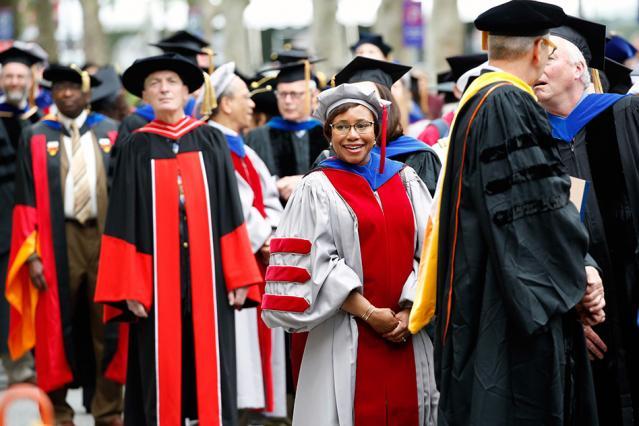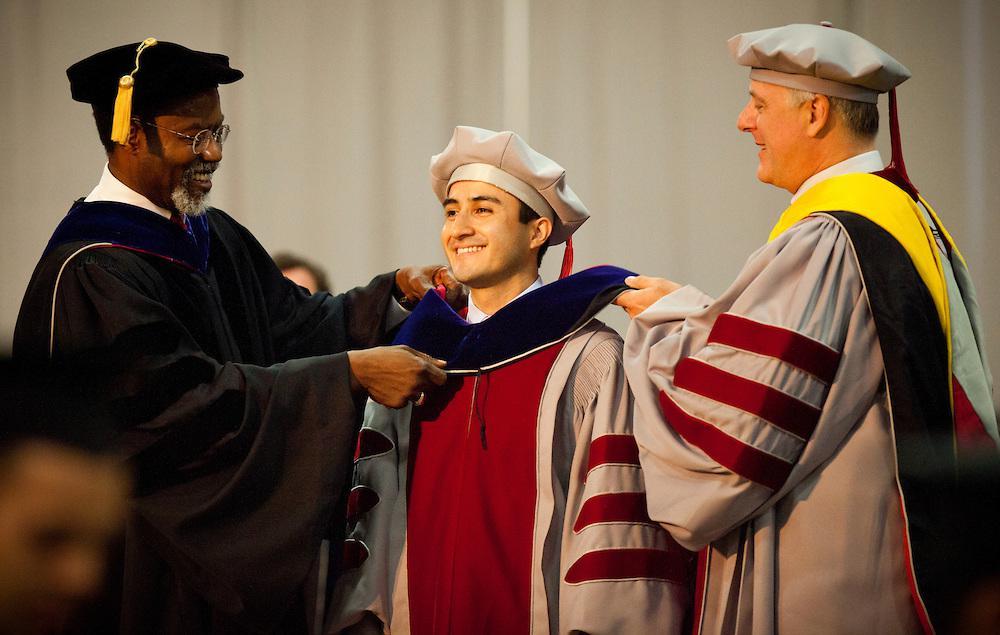The first image is the image on the left, the second image is the image on the right. For the images shown, is this caption "An image includes in the foreground a black bearded man in a black robe and tasseled square cap near a white man in a gray robe and beret-type hat." true? Answer yes or no. Yes. The first image is the image on the left, the second image is the image on the right. For the images displayed, is the sentence "The left image contains no more than three graduation students." factually correct? Answer yes or no. No. 